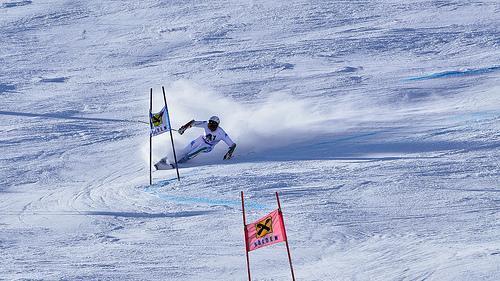How many snowboarders are there?
Give a very brief answer. 1. 